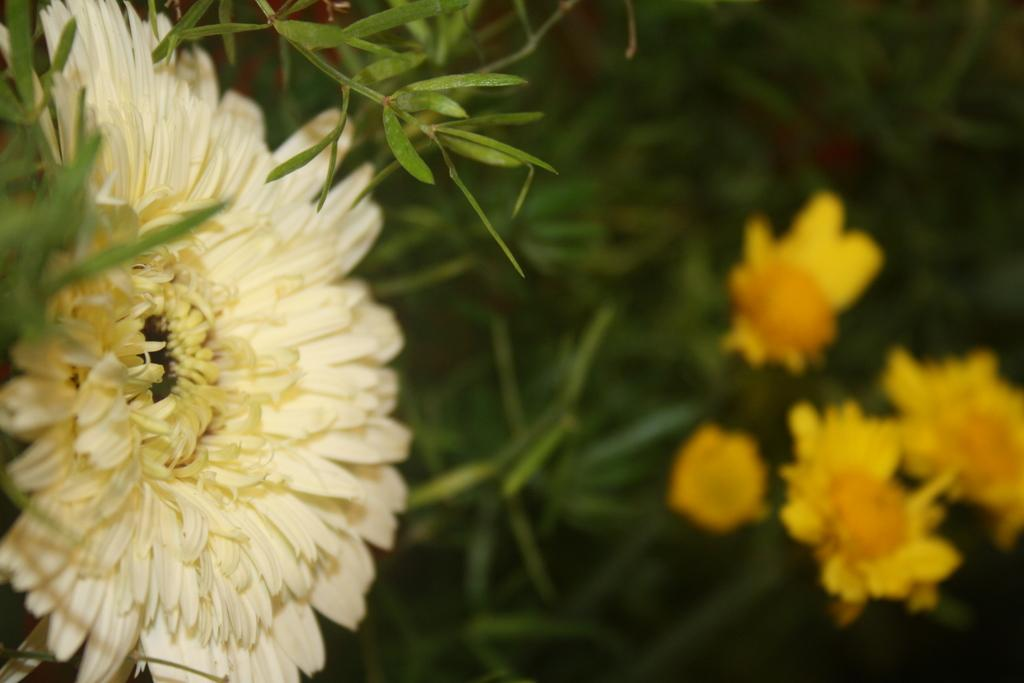What type of plants can be seen in the image? There are flowers and leaves in the image. Can you describe the appearance of the flowers? Unfortunately, the specific appearance of the flowers cannot be determined from the provided facts. Are there any other elements present in the image besides the flowers and leaves? No additional elements are mentioned in the provided facts. What type of silk is being used to make the pizzas in the image? There are no pizzas or silk present in the image; it features flowers and leaves. 